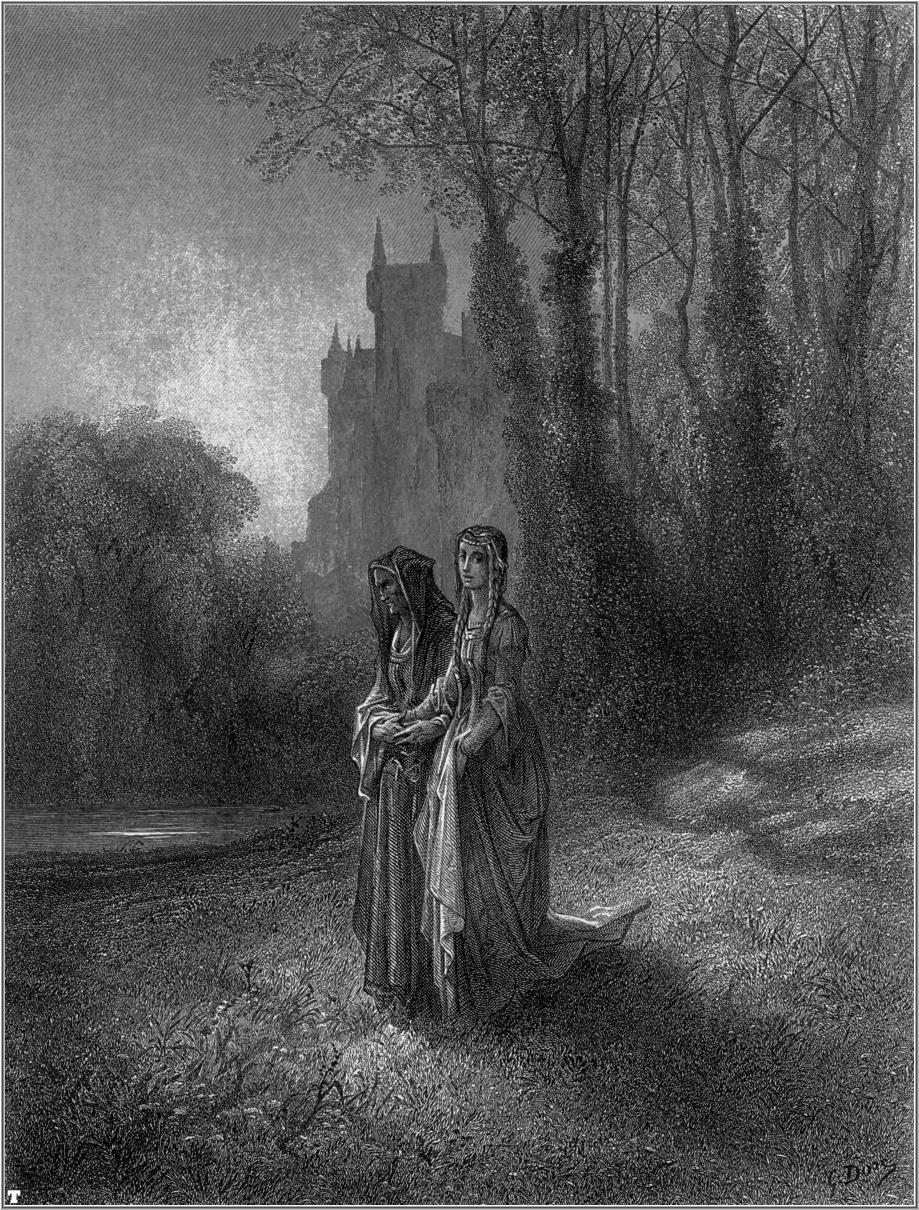Can you describe the atmosphere of the scene in the image? The atmosphere of the scene is tranquil and nostalgic. The soft shading and detailed textures evoke a sense of calm and introspection. The towering trees and distant castle create a majestic backdrop, while the two women walking together suggest companionship and quiet reflection. The forest's dense foliage and the play of light and shadow add a touch of mystery, enhancing the serene and almost ethereal quality of the moment captured in this illustration. 